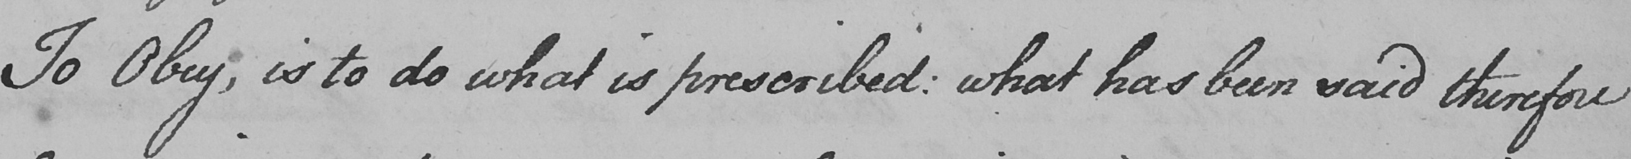Transcribe the text shown in this historical manuscript line. To Obey , is to do what is prescribed :  what has been said therefore 